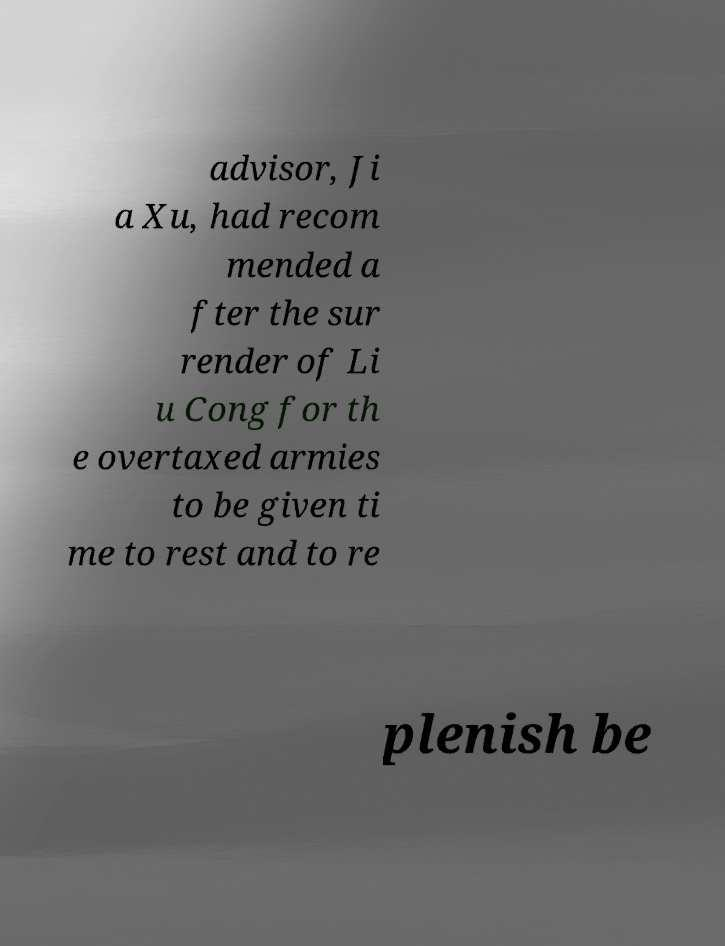Can you accurately transcribe the text from the provided image for me? advisor, Ji a Xu, had recom mended a fter the sur render of Li u Cong for th e overtaxed armies to be given ti me to rest and to re plenish be 